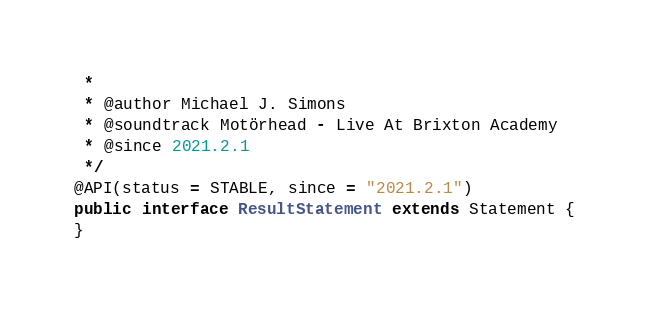Convert code to text. <code><loc_0><loc_0><loc_500><loc_500><_Java_> *
 * @author Michael J. Simons
 * @soundtrack Motörhead - Live At Brixton Academy
 * @since 2021.2.1
 */
@API(status = STABLE, since = "2021.2.1")
public interface ResultStatement extends Statement {
}
</code> 